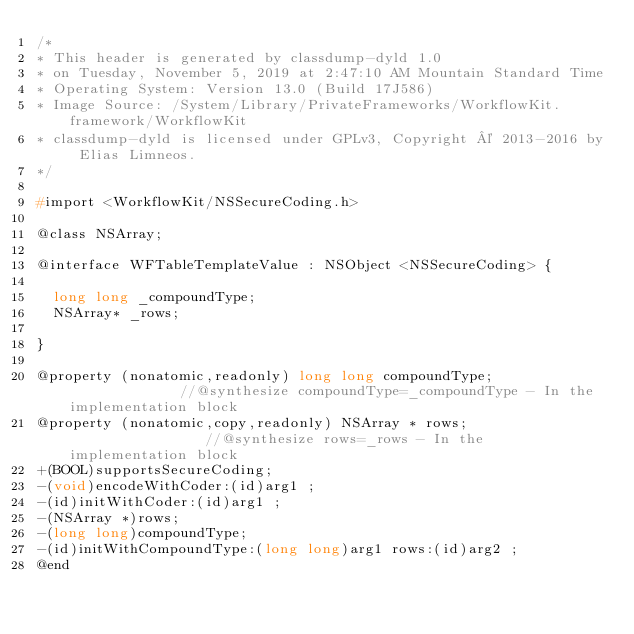<code> <loc_0><loc_0><loc_500><loc_500><_C_>/*
* This header is generated by classdump-dyld 1.0
* on Tuesday, November 5, 2019 at 2:47:10 AM Mountain Standard Time
* Operating System: Version 13.0 (Build 17J586)
* Image Source: /System/Library/PrivateFrameworks/WorkflowKit.framework/WorkflowKit
* classdump-dyld is licensed under GPLv3, Copyright © 2013-2016 by Elias Limneos.
*/

#import <WorkflowKit/NSSecureCoding.h>

@class NSArray;

@interface WFTableTemplateValue : NSObject <NSSecureCoding> {

	long long _compoundType;
	NSArray* _rows;

}

@property (nonatomic,readonly) long long compoundType;              //@synthesize compoundType=_compoundType - In the implementation block
@property (nonatomic,copy,readonly) NSArray * rows;                 //@synthesize rows=_rows - In the implementation block
+(BOOL)supportsSecureCoding;
-(void)encodeWithCoder:(id)arg1 ;
-(id)initWithCoder:(id)arg1 ;
-(NSArray *)rows;
-(long long)compoundType;
-(id)initWithCompoundType:(long long)arg1 rows:(id)arg2 ;
@end

</code> 